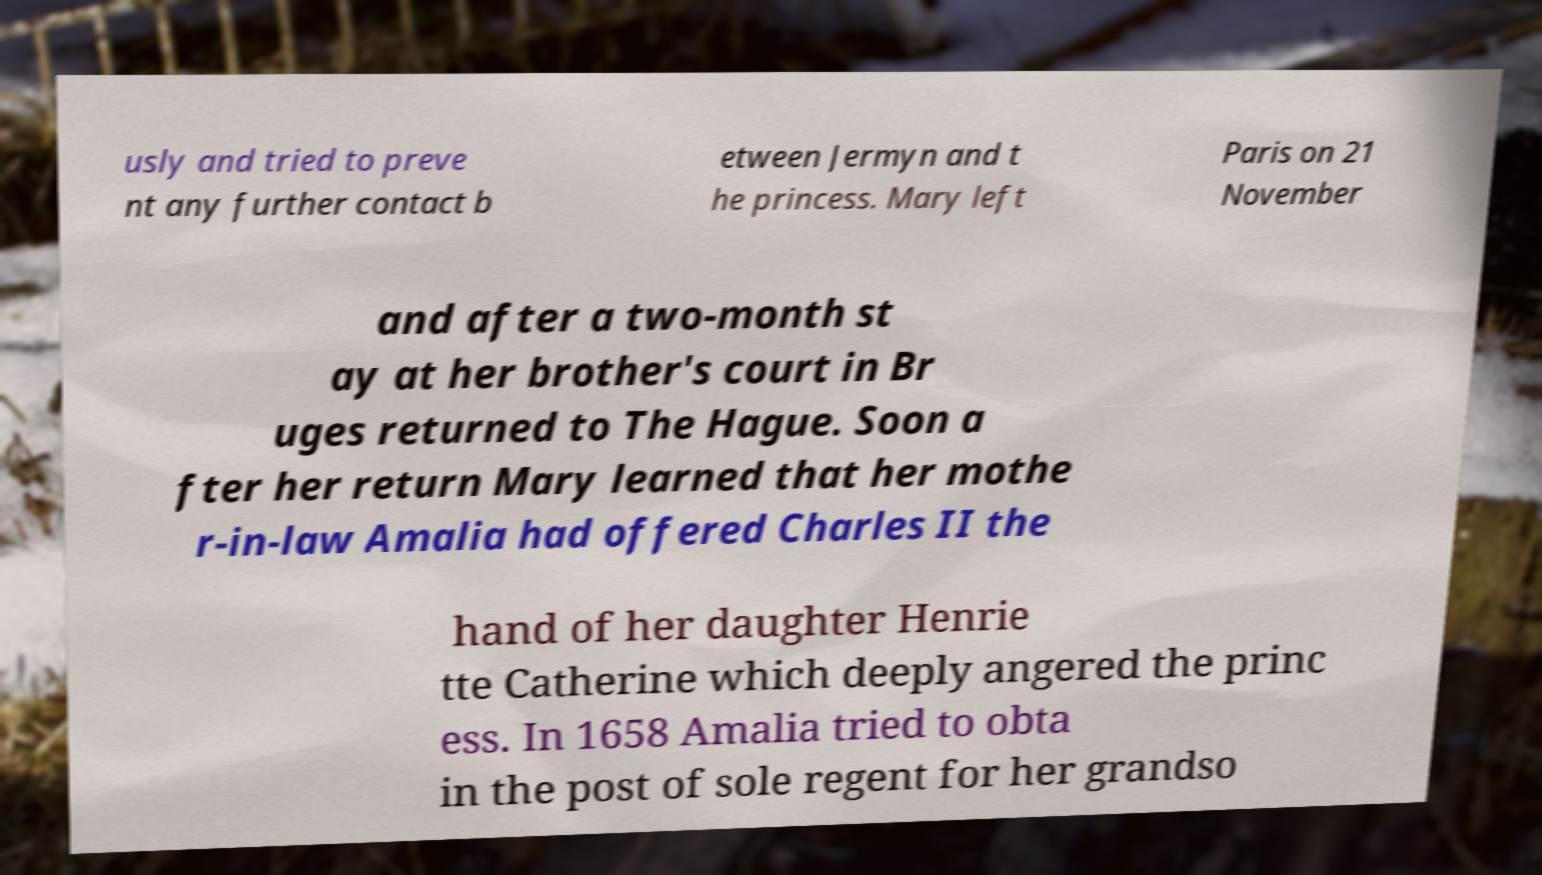There's text embedded in this image that I need extracted. Can you transcribe it verbatim? usly and tried to preve nt any further contact b etween Jermyn and t he princess. Mary left Paris on 21 November and after a two-month st ay at her brother's court in Br uges returned to The Hague. Soon a fter her return Mary learned that her mothe r-in-law Amalia had offered Charles II the hand of her daughter Henrie tte Catherine which deeply angered the princ ess. In 1658 Amalia tried to obta in the post of sole regent for her grandso 